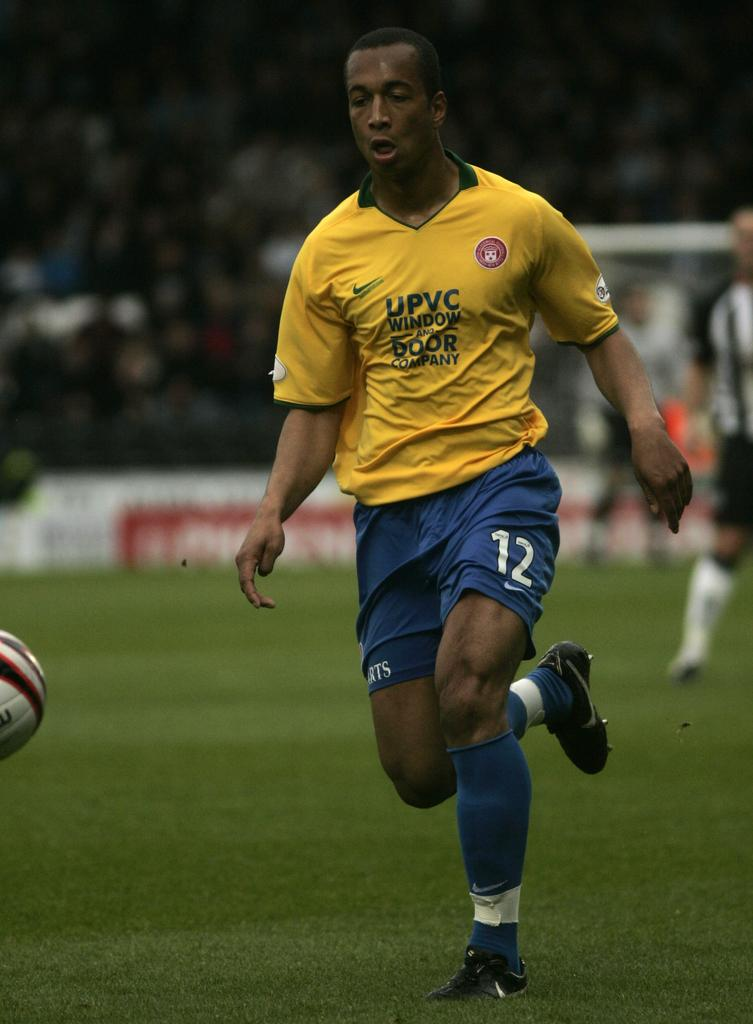What is the person in the image doing? The person is running in the image. On what surface is the person running? The person is running on the ground. What can be seen in the air on the left side of the image? There is a ball in the air on the left side of the image. What is the appearance of the background in the image? The background of the image has a blurred view. Are there any other people visible in the image? Yes, there are people visible in the background. What type of rock is being used as a slippery surface for the person to run on in the image? There is no rock present in the image, and the person is running on the ground, not a rock. 